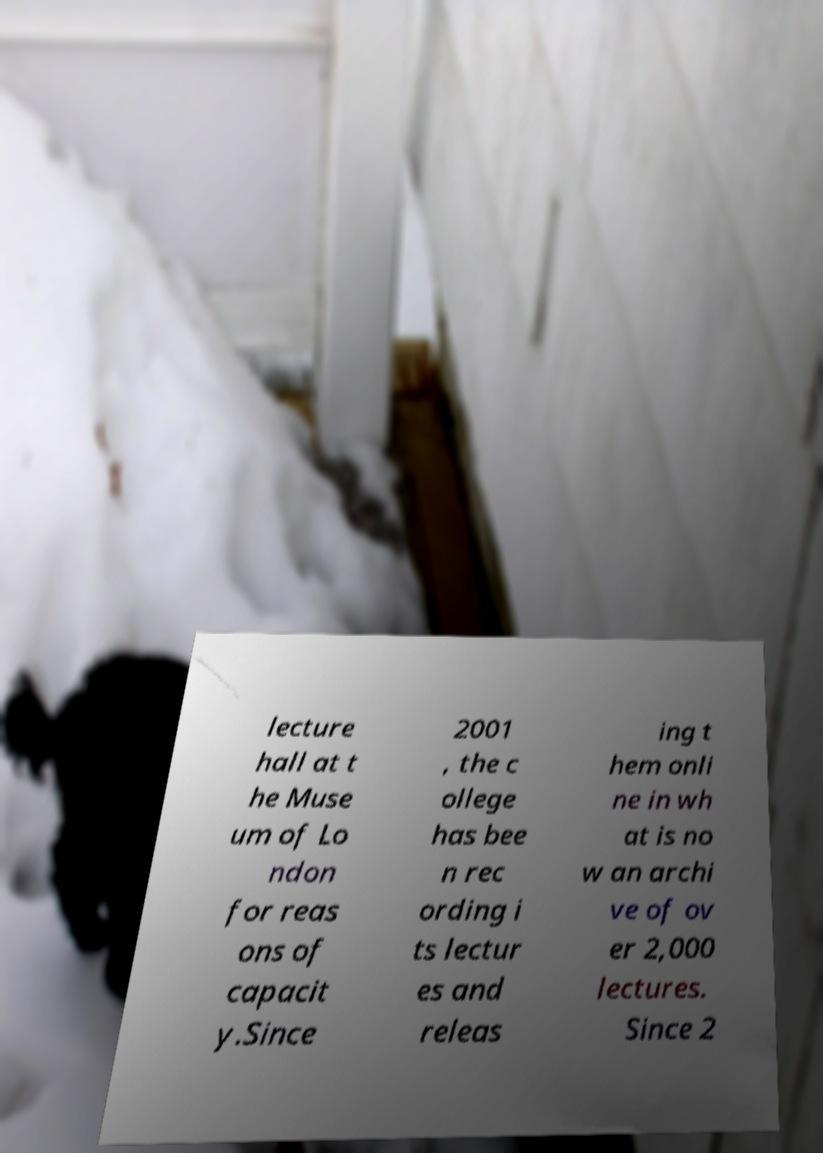Could you extract and type out the text from this image? lecture hall at t he Muse um of Lo ndon for reas ons of capacit y.Since 2001 , the c ollege has bee n rec ording i ts lectur es and releas ing t hem onli ne in wh at is no w an archi ve of ov er 2,000 lectures. Since 2 